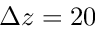<formula> <loc_0><loc_0><loc_500><loc_500>\Delta z = 2 0</formula> 